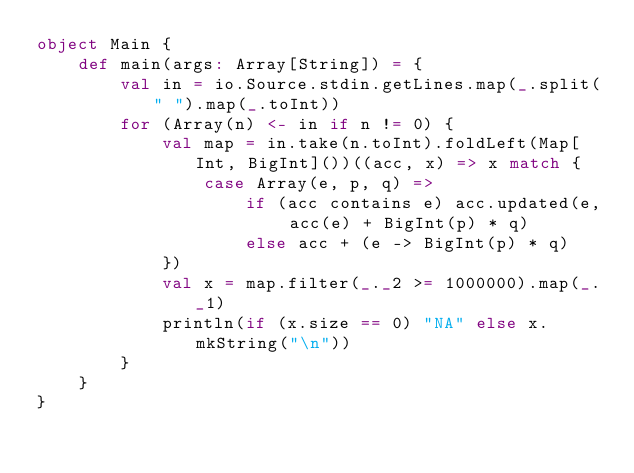<code> <loc_0><loc_0><loc_500><loc_500><_Scala_>object Main {
    def main(args: Array[String]) = {
        val in = io.Source.stdin.getLines.map(_.split(" ").map(_.toInt))
        for (Array(n) <- in if n != 0) {
            val map = in.take(n.toInt).foldLeft(Map[Int, BigInt]())((acc, x) => x match {
                case Array(e, p, q) =>
                    if (acc contains e) acc.updated(e, acc(e) + BigInt(p) * q)
                    else acc + (e -> BigInt(p) * q)
            })
            val x = map.filter(_._2 >= 1000000).map(_._1)
            println(if (x.size == 0) "NA" else x.mkString("\n"))
        }
    }
}</code> 